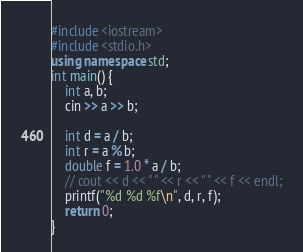<code> <loc_0><loc_0><loc_500><loc_500><_C++_>#include <iostream>
#include <stdio.h>
using namespace std;
int main() {
    int a, b;
    cin >> a >> b;

    int d = a / b;
    int r = a % b;
    double f = 1.0 * a / b;
    // cout << d << " " << r << " " << f << endl;
    printf("%d %d %f\n", d, r, f);
    return 0;
}
</code> 